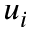<formula> <loc_0><loc_0><loc_500><loc_500>u _ { i }</formula> 